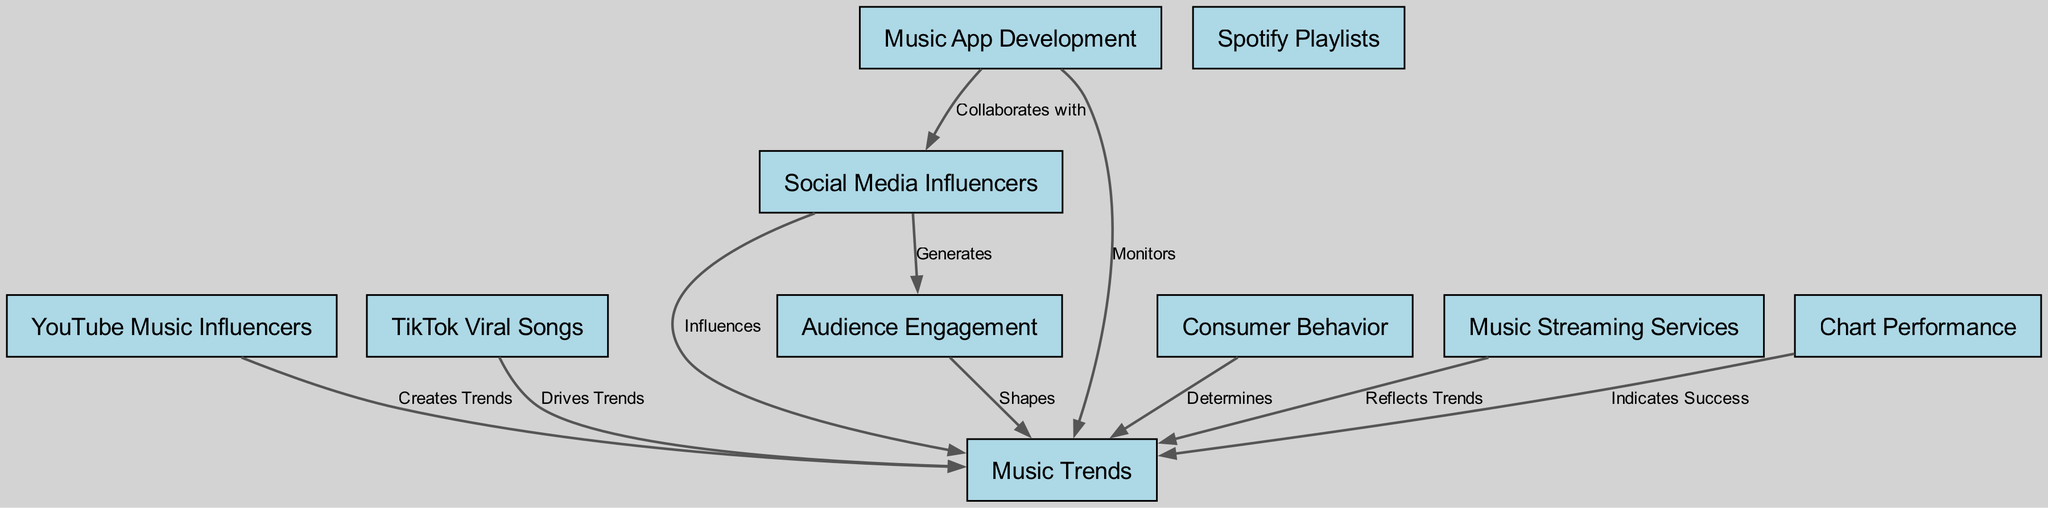What is the total number of nodes in the diagram? By counting the number of distinct entities listed in the nodes section of the data, we find there are 10 nodes which represent different components related to social media influencers and music trends.
Answer: 10 What label is connected to "YouTube Music Influencers"? The edge from "YouTube Music Influencers" points to "Music Trends" with the label "Creates Trends", indicating a direct influence on music trends.
Answer: Creates Trends Which node influences "Consumer Behavior"? The diagram shows an edge originating from "Social Media Influencers" which connects to "Consumer Behavior", indicating that social media influencers have an impact on how consumers behave in relation to music.
Answer: Social Media Influencers What do TikTok Viral Songs do in relation to music trends? The edge from "TikTok Viral Songs" to "Music Trends" is labeled "Drives Trends", indicating that viral songs on TikTok contribute positively to shaping music trends.
Answer: Drives Trends How do Music Streaming Services relate to Music Trends? The connection from "Music Streaming Services" to "Music Trends" with the label "Reflects Trends" implies that these services show or are indicative of existing music trends rather than forming them directly.
Answer: Reflects Trends What is the relationship between Audience Engagement and Music Trends? The connection shows that "Audience Engagement" shapes "Music Trends", meaning that how engaged the audience is will influence the current trends in music.
Answer: Shapes Which node collaborates with Music App Development? The diagram indicates that "Social Media Influencers" collaborates with "Music App Development", suggesting that influencers may work in conjunction with app developers to enhance music apps.
Answer: Social Media Influencers What indicates success in terms of music trends? The edge from "Chart Performance" to "Music Trends" labeled "Indicates Success" suggests that higher chart performance is a direct indicator of success for specific music trends.
Answer: Indicates Success What role does Music App Development play regarding music trends? "Music App Development" monitors "Music Trends", which means it actively keeps track of what trends are happening in the music scene.
Answer: Monitors 